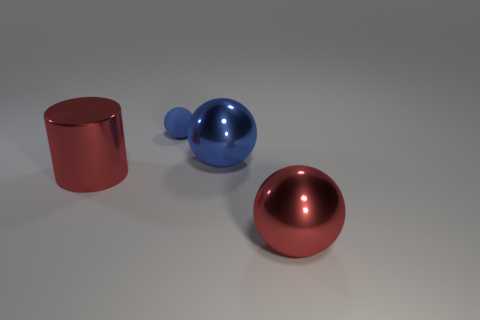The object that is on the left side of the tiny sphere left of the large red object on the right side of the large blue metal thing is what color?
Offer a very short reply. Red. What is the shape of the tiny blue rubber thing?
Ensure brevity in your answer.  Sphere. Is the color of the tiny matte thing the same as the large object that is left of the matte thing?
Your answer should be compact. No. Are there the same number of blue shiny balls that are behind the blue rubber object and small green matte cubes?
Give a very brief answer. Yes. What number of spheres have the same size as the cylinder?
Provide a short and direct response. 2. The metal thing that is the same color as the large metal cylinder is what shape?
Keep it short and to the point. Sphere. Are there any gray cylinders?
Keep it short and to the point. No. There is a large red metal thing that is left of the tiny ball; does it have the same shape as the blue object that is in front of the tiny ball?
Ensure brevity in your answer.  No. What number of tiny things are balls or rubber balls?
Make the answer very short. 1. There is a red thing that is made of the same material as the red sphere; what is its shape?
Provide a succinct answer. Cylinder. 